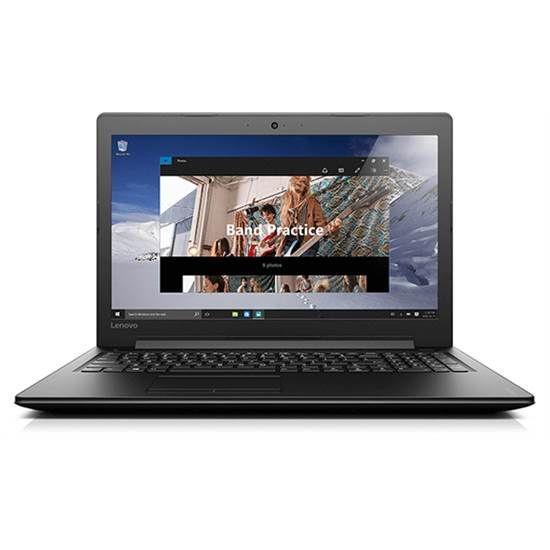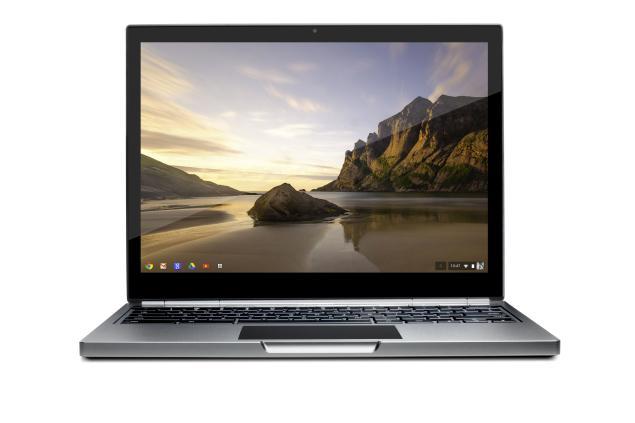The first image is the image on the left, the second image is the image on the right. Examine the images to the left and right. Is the description "there are two laptops fully open in the image pair" accurate? Answer yes or no. Yes. 